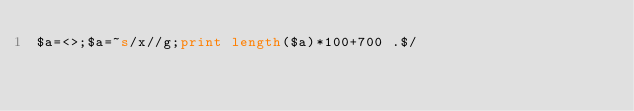<code> <loc_0><loc_0><loc_500><loc_500><_Perl_>$a=<>;$a=~s/x//g;print length($a)*100+700 .$/</code> 